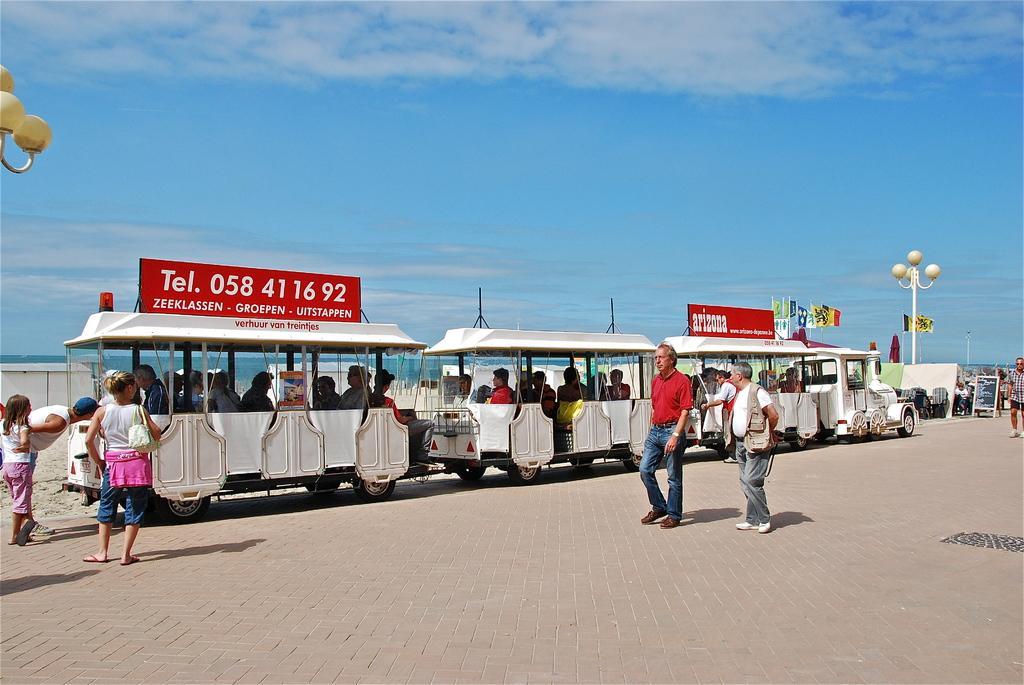Could you give a brief overview of what you see in this image? In this image there are group of people walking, and some of them are sitting in a train and there are some poles, lights, vehicles and objects. In the background there is a river, at the top there is sky and at the bottom there is a walkway. 